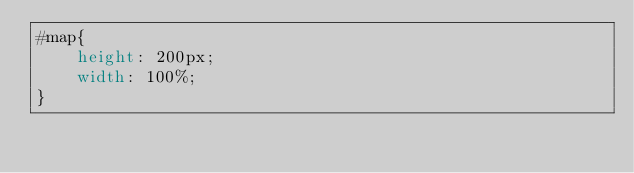Convert code to text. <code><loc_0><loc_0><loc_500><loc_500><_CSS_>#map{
    height: 200px;
    width: 100%;
}</code> 